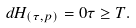Convert formula to latex. <formula><loc_0><loc_0><loc_500><loc_500>d H _ { ( \tau , p ) } = 0 \tau \geq T .</formula> 